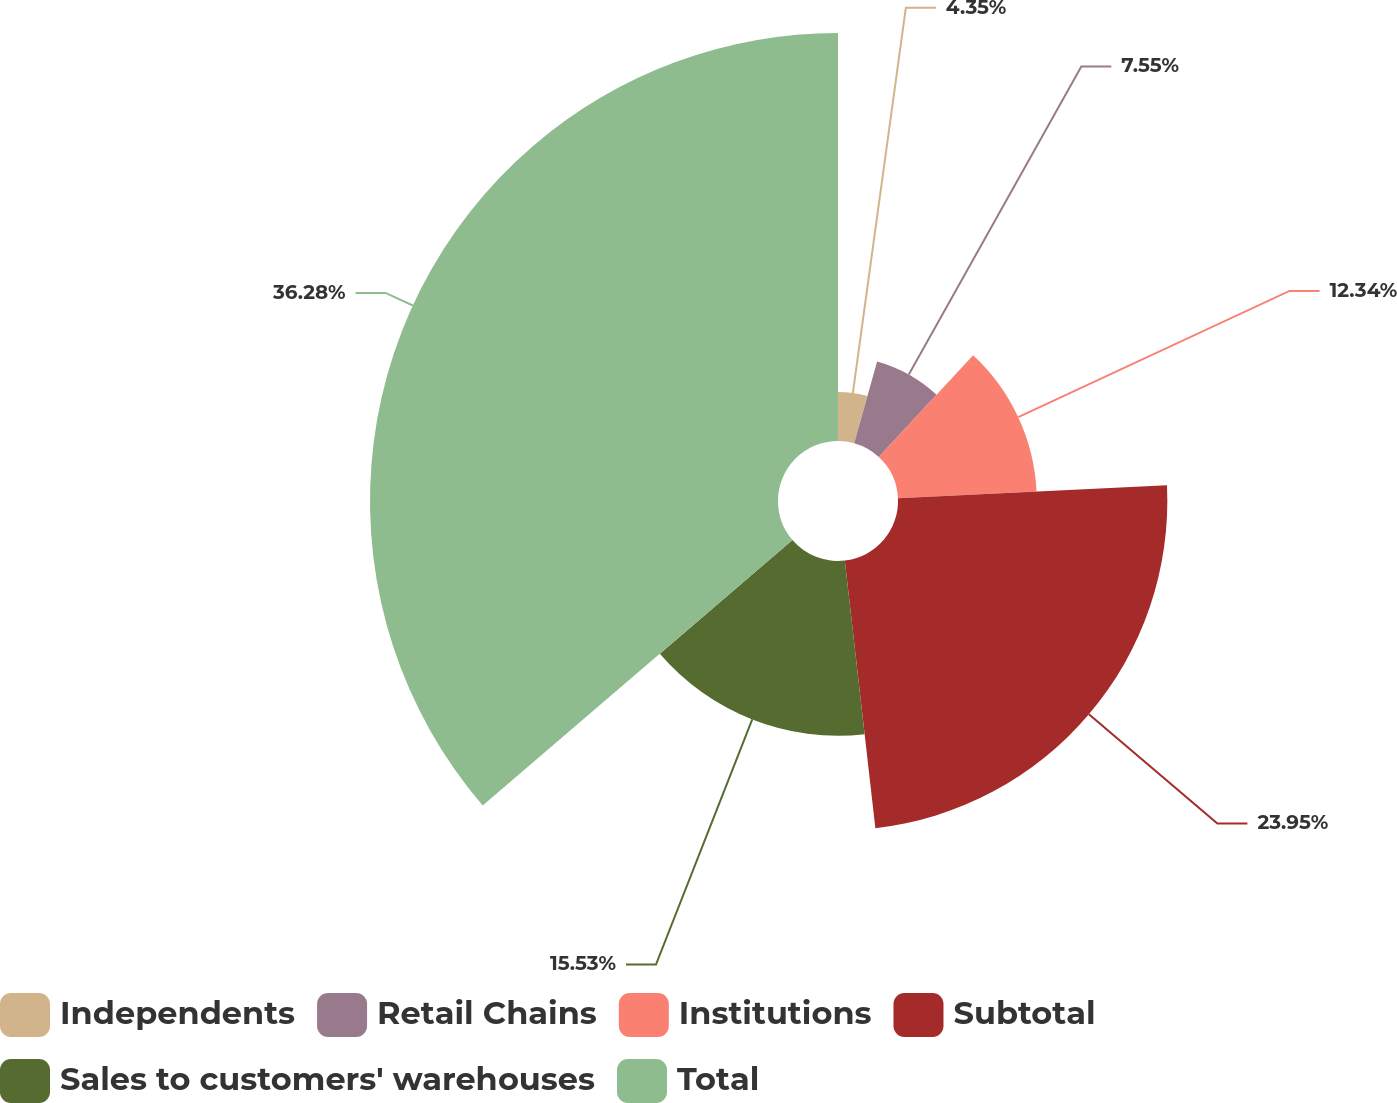<chart> <loc_0><loc_0><loc_500><loc_500><pie_chart><fcel>Independents<fcel>Retail Chains<fcel>Institutions<fcel>Subtotal<fcel>Sales to customers' warehouses<fcel>Total<nl><fcel>4.35%<fcel>7.55%<fcel>12.34%<fcel>23.95%<fcel>15.53%<fcel>36.28%<nl></chart> 